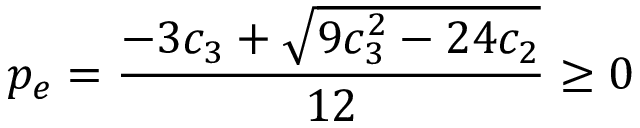Convert formula to latex. <formula><loc_0><loc_0><loc_500><loc_500>p _ { e } = \frac { - 3 c _ { 3 } + \sqrt { 9 c _ { 3 } ^ { 2 } - 2 4 c _ { 2 } } } { 1 2 } \geq 0</formula> 